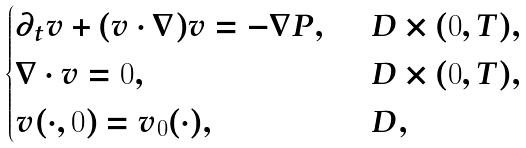<formula> <loc_0><loc_0><loc_500><loc_500>\begin{cases} \partial _ { t } v + ( v \cdot \nabla ) v = - \nabla P , \ \ & D \times ( 0 , T ) , \\ \nabla \cdot v = 0 , \ \ & D \times ( 0 , T ) , \\ v ( \cdot , 0 ) = v _ { 0 } ( \cdot ) , \ \ & D , \end{cases}</formula> 